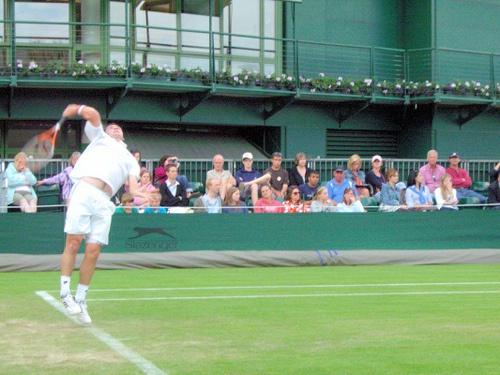Describe the objects in this image and their specific colors. I can see people in lightblue, white, lightpink, tan, and darkgray tones, people in lightblue, lightpink, lavender, gray, and darkgray tones, people in lightblue, lightgray, darkgray, and tan tones, tennis racket in lightblue, darkgray, brown, and gray tones, and people in lightblue, blue, gray, lightgray, and lightpink tones in this image. 